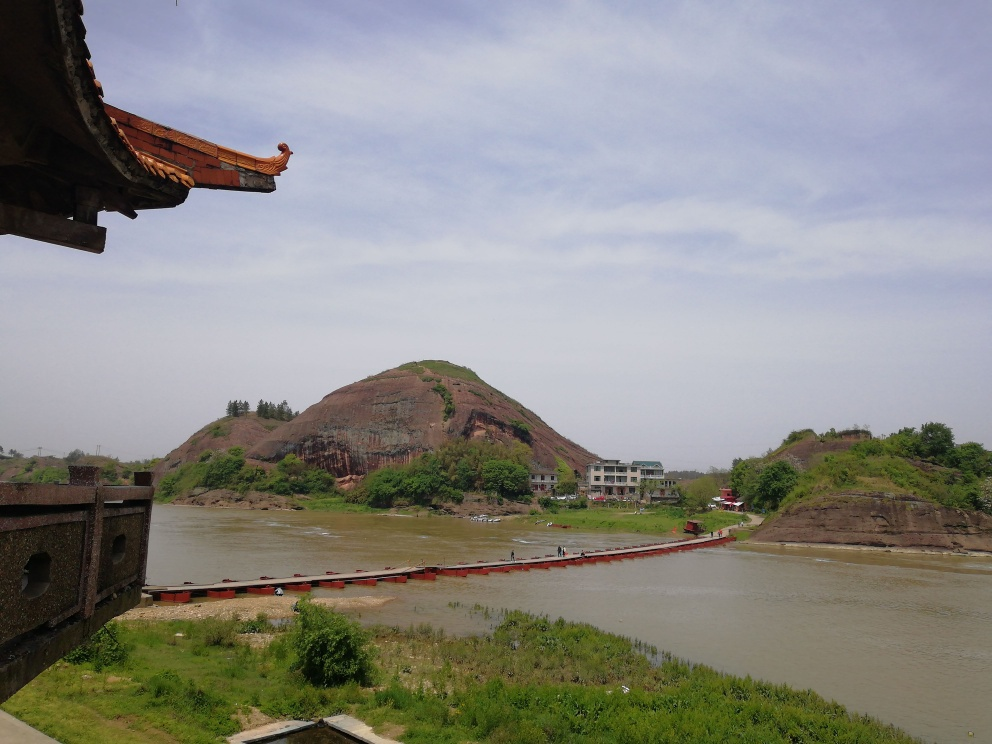What might be the ecological or environmental value of this area? Rivers and hills like those depicted in the image are often valuable ecosystems that support a wide range of flora and fauna. The river can serve as a habitat for aquatic life and provides water for surrounding vegetation. The hill's vegetation can help prevent soil erosion, offer a home for local wildlife, and act as a carbon sink, aiding in the mitigation of climate change. 